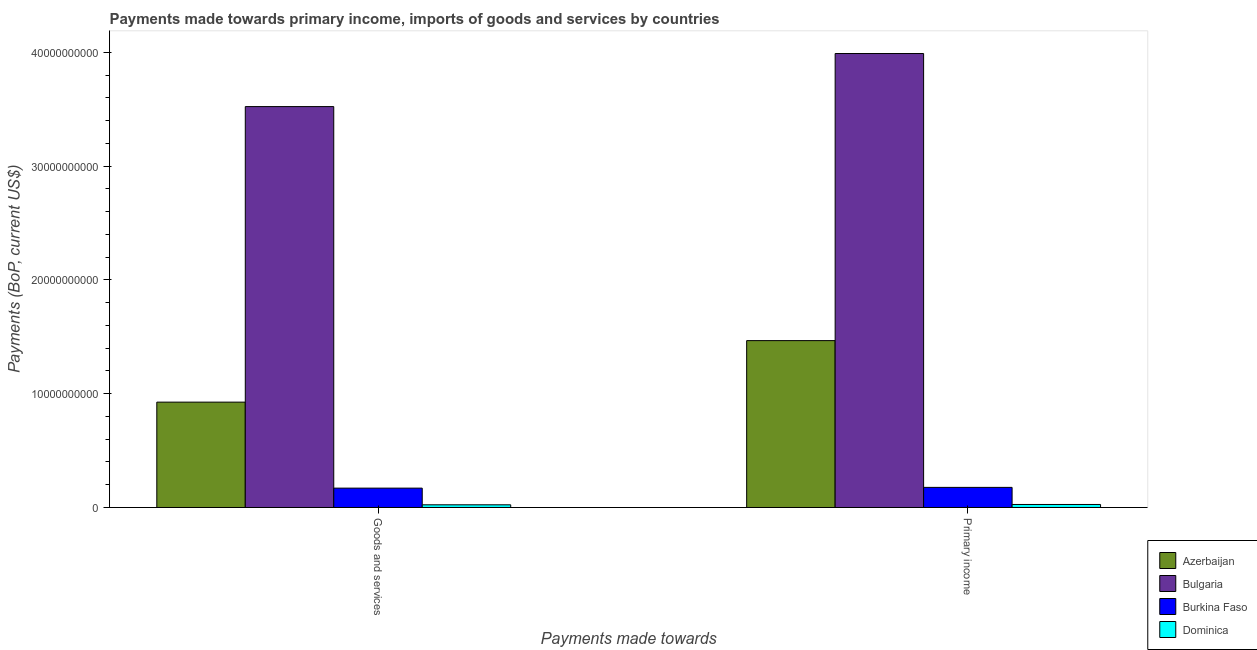Are the number of bars on each tick of the X-axis equal?
Your response must be concise. Yes. What is the label of the 2nd group of bars from the left?
Offer a terse response. Primary income. What is the payments made towards primary income in Burkina Faso?
Your response must be concise. 1.77e+09. Across all countries, what is the maximum payments made towards primary income?
Your response must be concise. 3.99e+1. Across all countries, what is the minimum payments made towards goods and services?
Offer a very short reply. 2.36e+08. In which country was the payments made towards goods and services minimum?
Give a very brief answer. Dominica. What is the total payments made towards primary income in the graph?
Keep it short and to the point. 5.66e+1. What is the difference between the payments made towards goods and services in Bulgaria and that in Burkina Faso?
Provide a succinct answer. 3.35e+1. What is the difference between the payments made towards primary income in Azerbaijan and the payments made towards goods and services in Bulgaria?
Ensure brevity in your answer.  -2.06e+1. What is the average payments made towards goods and services per country?
Your answer should be compact. 1.16e+1. What is the difference between the payments made towards goods and services and payments made towards primary income in Bulgaria?
Your answer should be compact. -4.67e+09. In how many countries, is the payments made towards primary income greater than 24000000000 US$?
Keep it short and to the point. 1. What is the ratio of the payments made towards goods and services in Bulgaria to that in Dominica?
Your answer should be compact. 149.13. What does the 1st bar from the left in Goods and services represents?
Offer a very short reply. Azerbaijan. How many countries are there in the graph?
Offer a terse response. 4. Does the graph contain any zero values?
Offer a terse response. No. How many legend labels are there?
Your response must be concise. 4. How are the legend labels stacked?
Keep it short and to the point. Vertical. What is the title of the graph?
Provide a succinct answer. Payments made towards primary income, imports of goods and services by countries. What is the label or title of the X-axis?
Make the answer very short. Payments made towards. What is the label or title of the Y-axis?
Your response must be concise. Payments (BoP, current US$). What is the Payments (BoP, current US$) of Azerbaijan in Goods and services?
Provide a succinct answer. 9.26e+09. What is the Payments (BoP, current US$) in Bulgaria in Goods and services?
Your answer should be very brief. 3.52e+1. What is the Payments (BoP, current US$) in Burkina Faso in Goods and services?
Your response must be concise. 1.70e+09. What is the Payments (BoP, current US$) in Dominica in Goods and services?
Keep it short and to the point. 2.36e+08. What is the Payments (BoP, current US$) in Azerbaijan in Primary income?
Make the answer very short. 1.47e+1. What is the Payments (BoP, current US$) in Bulgaria in Primary income?
Your response must be concise. 3.99e+1. What is the Payments (BoP, current US$) of Burkina Faso in Primary income?
Your answer should be compact. 1.77e+09. What is the Payments (BoP, current US$) in Dominica in Primary income?
Offer a terse response. 2.64e+08. Across all Payments made towards, what is the maximum Payments (BoP, current US$) of Azerbaijan?
Provide a short and direct response. 1.47e+1. Across all Payments made towards, what is the maximum Payments (BoP, current US$) in Bulgaria?
Provide a succinct answer. 3.99e+1. Across all Payments made towards, what is the maximum Payments (BoP, current US$) of Burkina Faso?
Your response must be concise. 1.77e+09. Across all Payments made towards, what is the maximum Payments (BoP, current US$) of Dominica?
Keep it short and to the point. 2.64e+08. Across all Payments made towards, what is the minimum Payments (BoP, current US$) in Azerbaijan?
Offer a very short reply. 9.26e+09. Across all Payments made towards, what is the minimum Payments (BoP, current US$) of Bulgaria?
Provide a succinct answer. 3.52e+1. Across all Payments made towards, what is the minimum Payments (BoP, current US$) in Burkina Faso?
Your answer should be compact. 1.70e+09. Across all Payments made towards, what is the minimum Payments (BoP, current US$) in Dominica?
Your response must be concise. 2.36e+08. What is the total Payments (BoP, current US$) in Azerbaijan in the graph?
Your answer should be compact. 2.39e+1. What is the total Payments (BoP, current US$) of Bulgaria in the graph?
Keep it short and to the point. 7.52e+1. What is the total Payments (BoP, current US$) in Burkina Faso in the graph?
Your answer should be very brief. 3.47e+09. What is the total Payments (BoP, current US$) of Dominica in the graph?
Make the answer very short. 5.01e+08. What is the difference between the Payments (BoP, current US$) in Azerbaijan in Goods and services and that in Primary income?
Make the answer very short. -5.41e+09. What is the difference between the Payments (BoP, current US$) in Bulgaria in Goods and services and that in Primary income?
Give a very brief answer. -4.67e+09. What is the difference between the Payments (BoP, current US$) of Burkina Faso in Goods and services and that in Primary income?
Provide a succinct answer. -6.57e+07. What is the difference between the Payments (BoP, current US$) in Dominica in Goods and services and that in Primary income?
Offer a terse response. -2.82e+07. What is the difference between the Payments (BoP, current US$) in Azerbaijan in Goods and services and the Payments (BoP, current US$) in Bulgaria in Primary income?
Provide a short and direct response. -3.06e+1. What is the difference between the Payments (BoP, current US$) of Azerbaijan in Goods and services and the Payments (BoP, current US$) of Burkina Faso in Primary income?
Offer a very short reply. 7.49e+09. What is the difference between the Payments (BoP, current US$) of Azerbaijan in Goods and services and the Payments (BoP, current US$) of Dominica in Primary income?
Make the answer very short. 9.00e+09. What is the difference between the Payments (BoP, current US$) of Bulgaria in Goods and services and the Payments (BoP, current US$) of Burkina Faso in Primary income?
Your answer should be compact. 3.35e+1. What is the difference between the Payments (BoP, current US$) in Bulgaria in Goods and services and the Payments (BoP, current US$) in Dominica in Primary income?
Your answer should be very brief. 3.50e+1. What is the difference between the Payments (BoP, current US$) of Burkina Faso in Goods and services and the Payments (BoP, current US$) of Dominica in Primary income?
Give a very brief answer. 1.44e+09. What is the average Payments (BoP, current US$) in Azerbaijan per Payments made towards?
Keep it short and to the point. 1.20e+1. What is the average Payments (BoP, current US$) in Bulgaria per Payments made towards?
Your response must be concise. 3.76e+1. What is the average Payments (BoP, current US$) in Burkina Faso per Payments made towards?
Give a very brief answer. 1.73e+09. What is the average Payments (BoP, current US$) of Dominica per Payments made towards?
Offer a terse response. 2.50e+08. What is the difference between the Payments (BoP, current US$) of Azerbaijan and Payments (BoP, current US$) of Bulgaria in Goods and services?
Provide a short and direct response. -2.60e+1. What is the difference between the Payments (BoP, current US$) in Azerbaijan and Payments (BoP, current US$) in Burkina Faso in Goods and services?
Offer a terse response. 7.56e+09. What is the difference between the Payments (BoP, current US$) of Azerbaijan and Payments (BoP, current US$) of Dominica in Goods and services?
Your answer should be very brief. 9.03e+09. What is the difference between the Payments (BoP, current US$) in Bulgaria and Payments (BoP, current US$) in Burkina Faso in Goods and services?
Provide a short and direct response. 3.35e+1. What is the difference between the Payments (BoP, current US$) in Bulgaria and Payments (BoP, current US$) in Dominica in Goods and services?
Your response must be concise. 3.50e+1. What is the difference between the Payments (BoP, current US$) of Burkina Faso and Payments (BoP, current US$) of Dominica in Goods and services?
Your answer should be very brief. 1.47e+09. What is the difference between the Payments (BoP, current US$) in Azerbaijan and Payments (BoP, current US$) in Bulgaria in Primary income?
Give a very brief answer. -2.52e+1. What is the difference between the Payments (BoP, current US$) in Azerbaijan and Payments (BoP, current US$) in Burkina Faso in Primary income?
Make the answer very short. 1.29e+1. What is the difference between the Payments (BoP, current US$) in Azerbaijan and Payments (BoP, current US$) in Dominica in Primary income?
Keep it short and to the point. 1.44e+1. What is the difference between the Payments (BoP, current US$) in Bulgaria and Payments (BoP, current US$) in Burkina Faso in Primary income?
Provide a succinct answer. 3.81e+1. What is the difference between the Payments (BoP, current US$) of Bulgaria and Payments (BoP, current US$) of Dominica in Primary income?
Ensure brevity in your answer.  3.96e+1. What is the difference between the Payments (BoP, current US$) in Burkina Faso and Payments (BoP, current US$) in Dominica in Primary income?
Give a very brief answer. 1.50e+09. What is the ratio of the Payments (BoP, current US$) in Azerbaijan in Goods and services to that in Primary income?
Your answer should be very brief. 0.63. What is the ratio of the Payments (BoP, current US$) of Bulgaria in Goods and services to that in Primary income?
Keep it short and to the point. 0.88. What is the ratio of the Payments (BoP, current US$) in Burkina Faso in Goods and services to that in Primary income?
Ensure brevity in your answer.  0.96. What is the ratio of the Payments (BoP, current US$) of Dominica in Goods and services to that in Primary income?
Keep it short and to the point. 0.89. What is the difference between the highest and the second highest Payments (BoP, current US$) in Azerbaijan?
Offer a very short reply. 5.41e+09. What is the difference between the highest and the second highest Payments (BoP, current US$) in Bulgaria?
Offer a terse response. 4.67e+09. What is the difference between the highest and the second highest Payments (BoP, current US$) in Burkina Faso?
Give a very brief answer. 6.57e+07. What is the difference between the highest and the second highest Payments (BoP, current US$) of Dominica?
Keep it short and to the point. 2.82e+07. What is the difference between the highest and the lowest Payments (BoP, current US$) in Azerbaijan?
Offer a very short reply. 5.41e+09. What is the difference between the highest and the lowest Payments (BoP, current US$) of Bulgaria?
Offer a terse response. 4.67e+09. What is the difference between the highest and the lowest Payments (BoP, current US$) in Burkina Faso?
Your response must be concise. 6.57e+07. What is the difference between the highest and the lowest Payments (BoP, current US$) in Dominica?
Keep it short and to the point. 2.82e+07. 